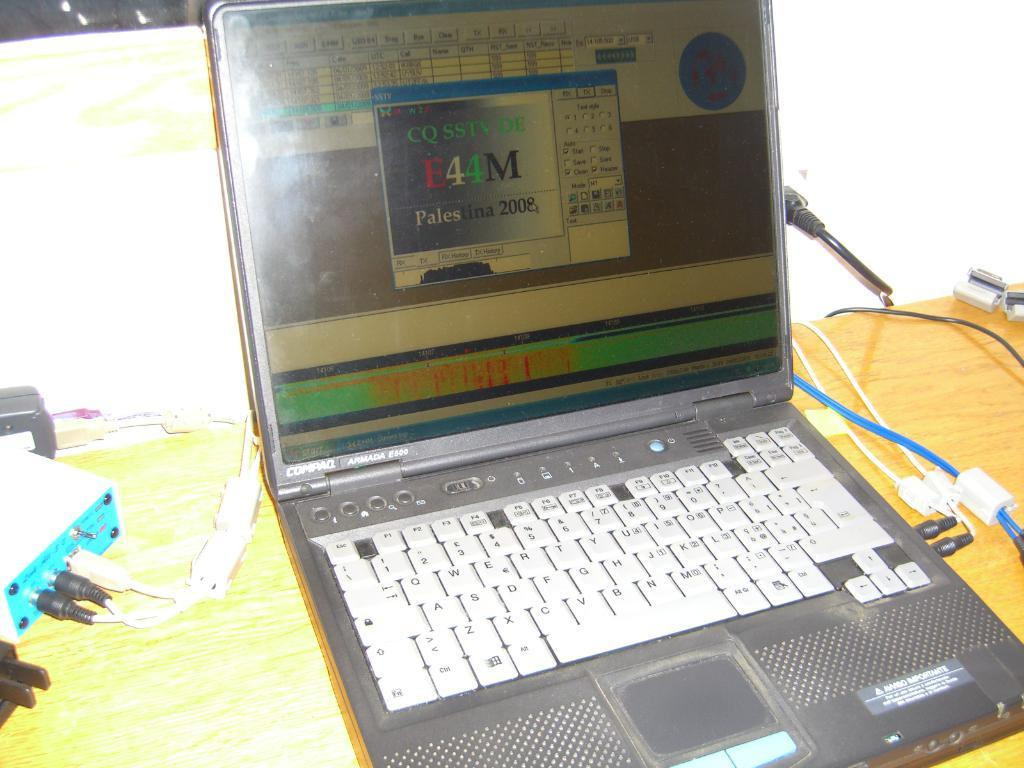<image>
Present a compact description of the photo's key features. A laptop computer is opened and one tab reads CQ SSTV 